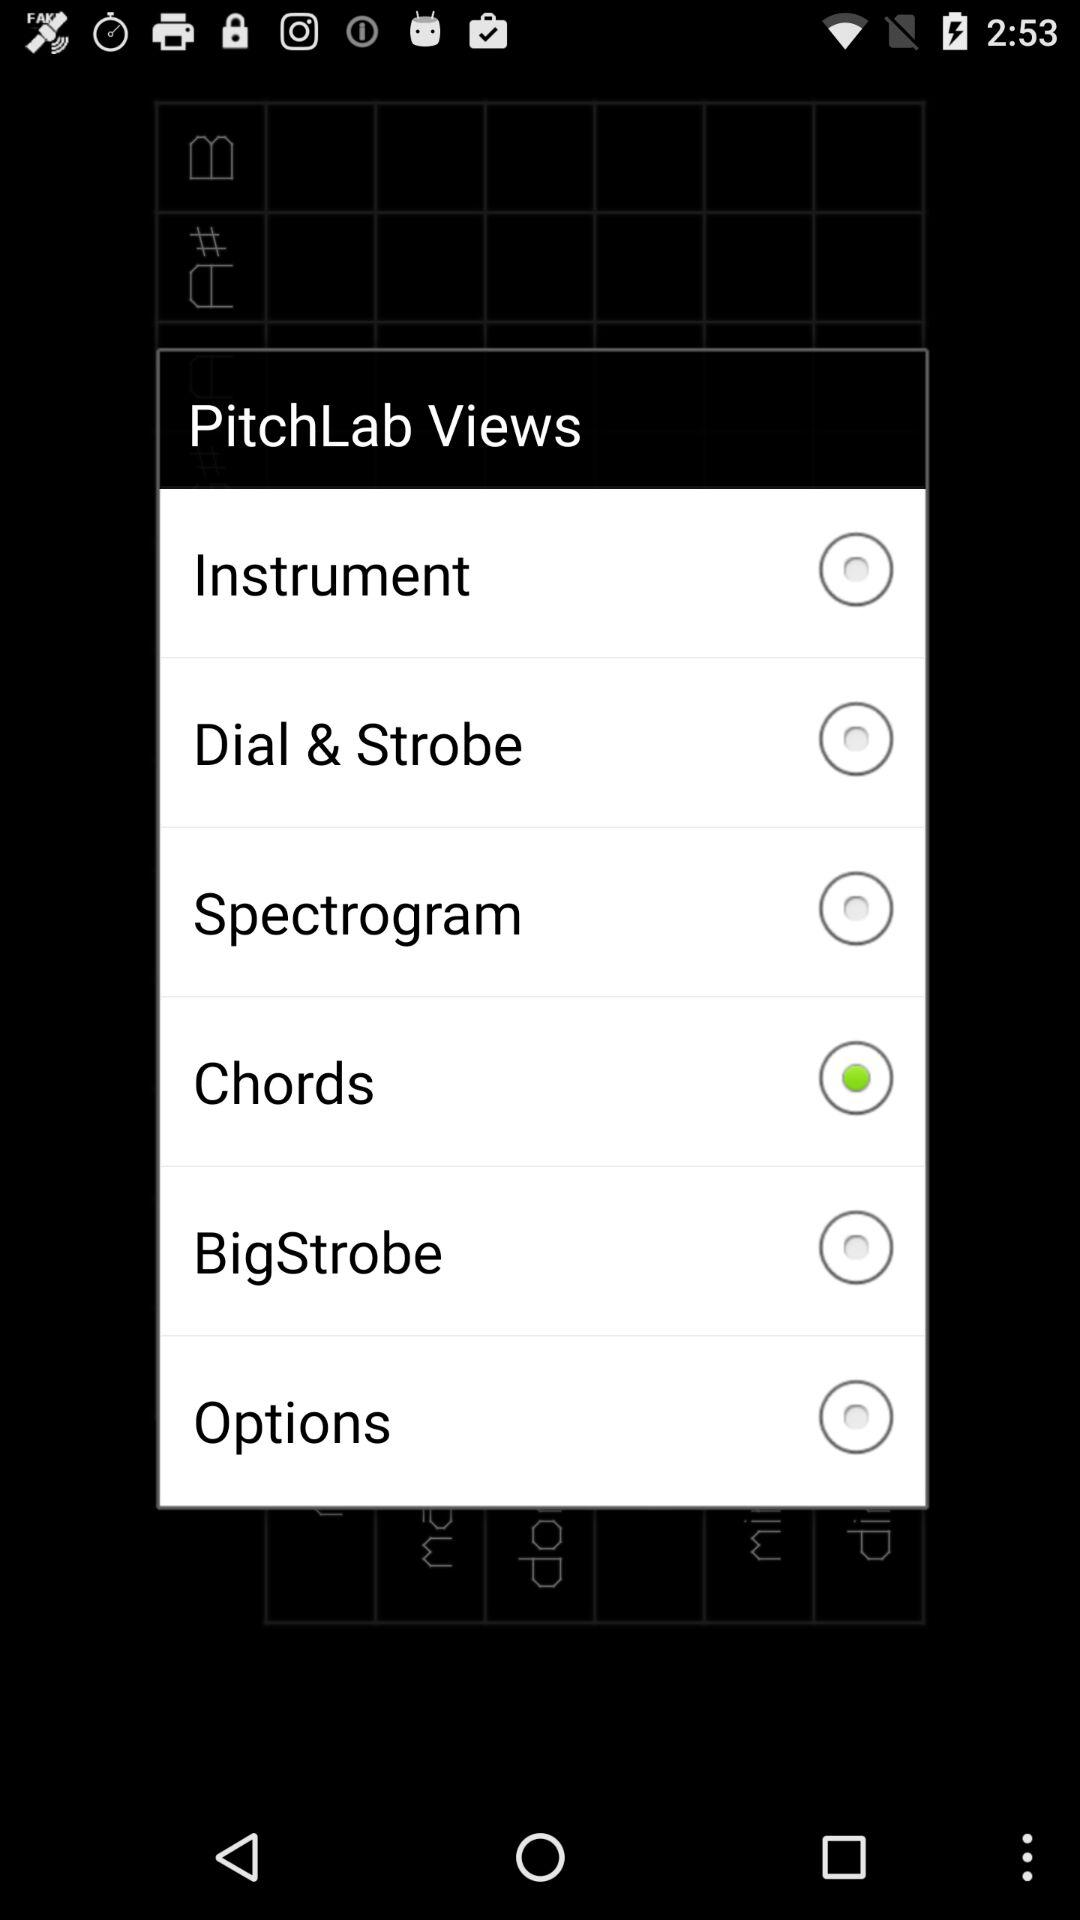Is "Chords" selected or not?
Answer the question using a single word or phrase. "Chords" is selected. 